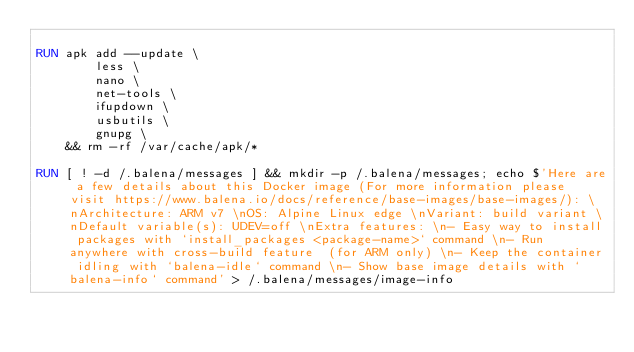Convert code to text. <code><loc_0><loc_0><loc_500><loc_500><_Dockerfile_>
RUN apk add --update \
		less \
		nano \
		net-tools \
		ifupdown \
		usbutils \
		gnupg \
	&& rm -rf /var/cache/apk/*

RUN [ ! -d /.balena/messages ] && mkdir -p /.balena/messages; echo $'Here are a few details about this Docker image (For more information please visit https://www.balena.io/docs/reference/base-images/base-images/): \nArchitecture: ARM v7 \nOS: Alpine Linux edge \nVariant: build variant \nDefault variable(s): UDEV=off \nExtra features: \n- Easy way to install packages with `install_packages <package-name>` command \n- Run anywhere with cross-build feature  (for ARM only) \n- Keep the container idling with `balena-idle` command \n- Show base image details with `balena-info` command' > /.balena/messages/image-info</code> 